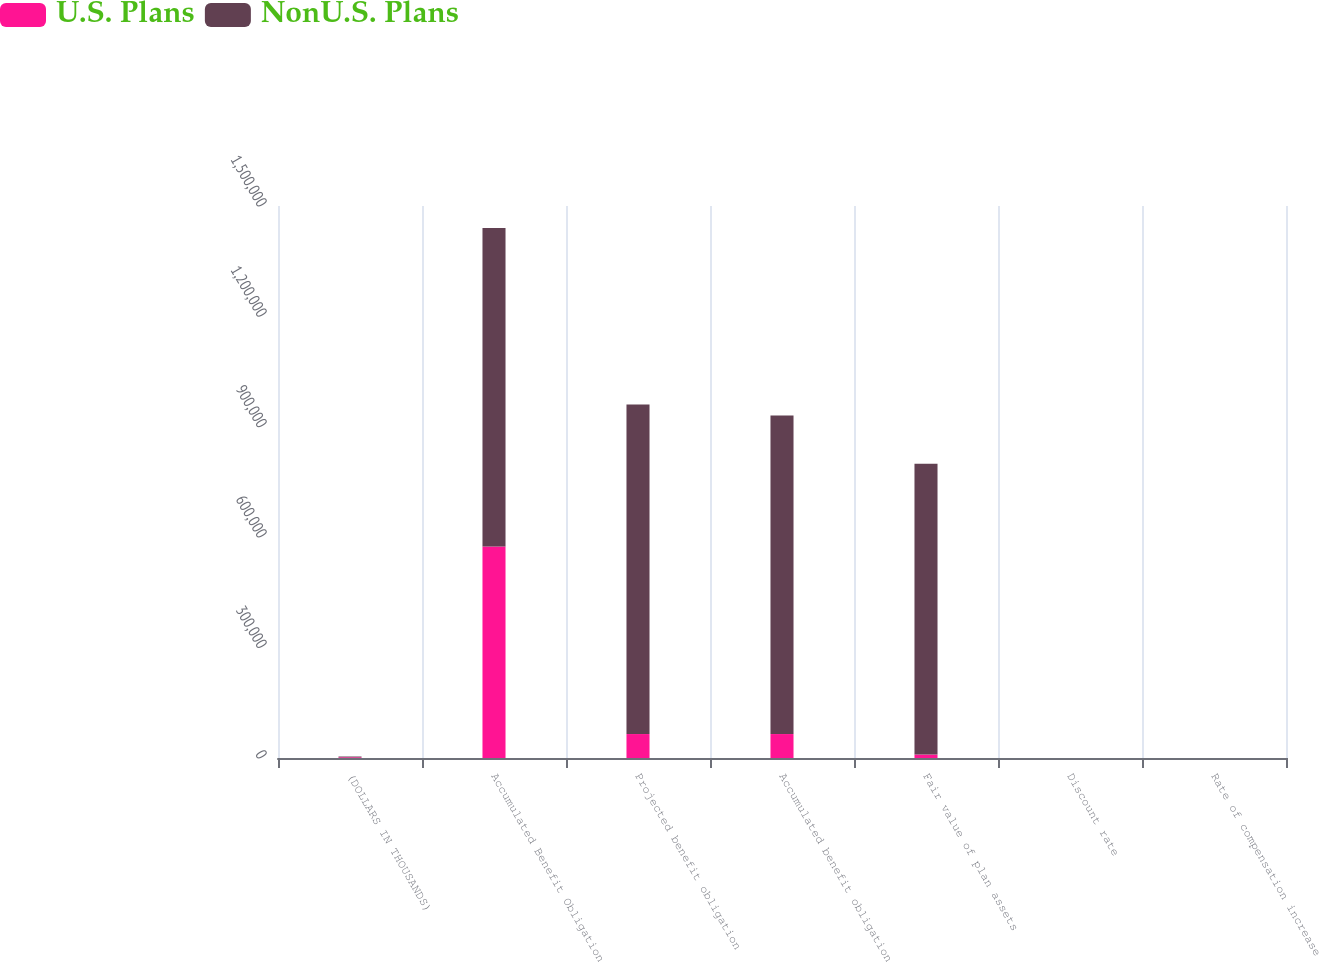<chart> <loc_0><loc_0><loc_500><loc_500><stacked_bar_chart><ecel><fcel>(DOLLARS IN THOUSANDS)<fcel>Accumulated Benefit Obligation<fcel>Projected benefit obligation<fcel>Accumulated benefit obligation<fcel>Fair value of plan assets<fcel>Discount rate<fcel>Rate of compensation increase<nl><fcel>U.S. Plans<fcel>2016<fcel>574612<fcel>65101<fcel>65101<fcel>9389<fcel>4.2<fcel>3.25<nl><fcel>NonU.S. Plans<fcel>2016<fcel>865585<fcel>895566<fcel>865585<fcel>790218<fcel>2.14<fcel>1.97<nl></chart> 